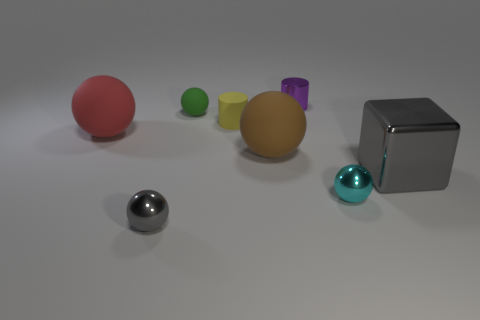How many objects are brown balls or tiny gray shiny things?
Your response must be concise. 2. Are there any gray things behind the small gray metallic ball?
Provide a succinct answer. Yes. Is there a small gray ball made of the same material as the purple thing?
Keep it short and to the point. Yes. What size is the other thing that is the same color as the big metal thing?
Provide a short and direct response. Small. How many cubes are small purple objects or small cyan metallic things?
Offer a very short reply. 0. Is the number of rubber objects in front of the small matte sphere greater than the number of spheres in front of the red sphere?
Provide a short and direct response. No. How many shiny spheres have the same color as the big cube?
Your answer should be compact. 1. What is the size of the cube that is the same material as the purple thing?
Your response must be concise. Large. What number of things are tiny metallic objects right of the yellow cylinder or big red spheres?
Provide a short and direct response. 3. There is a tiny metal object behind the gray metallic cube; is it the same color as the large metal object?
Your answer should be very brief. No. 